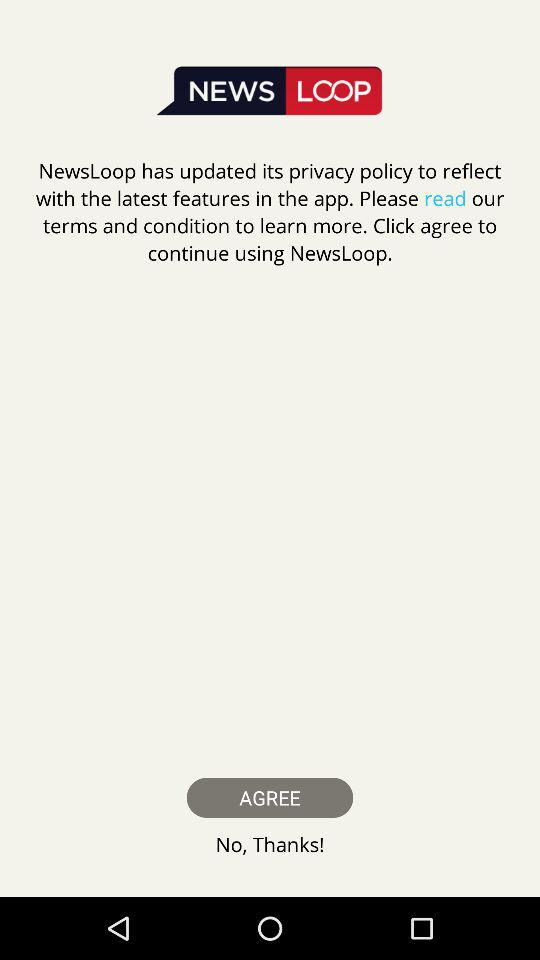What is the application name? The application name is "News Loop". 